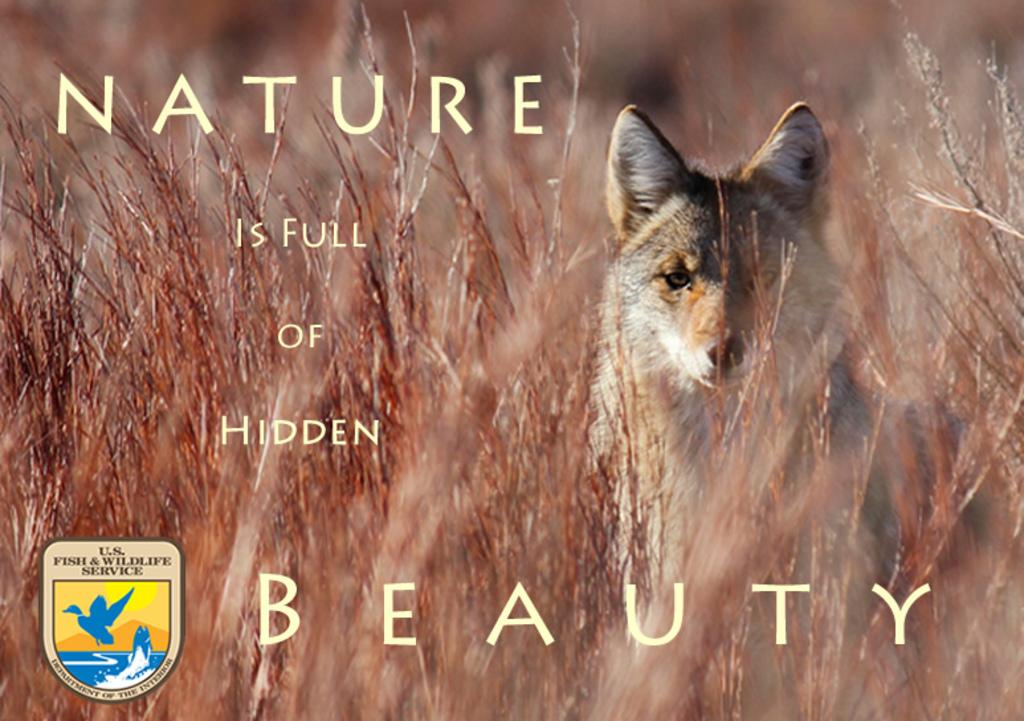What type of living organisms can be seen in the image? Plants are visible in the image. What animal is present behind the plants? There is a fox behind the plants. What else is featured on the image besides the plants and fox? There is text on the image. Where is the logo located in the image? The logo is in the bottom left corner of the image. How would you describe the overall appearance of the image? The image appears to be a poster. What type of pie is being suggested by the fox in the image? There is no pie present in the image, nor is there any suggestion being made by the fox. 